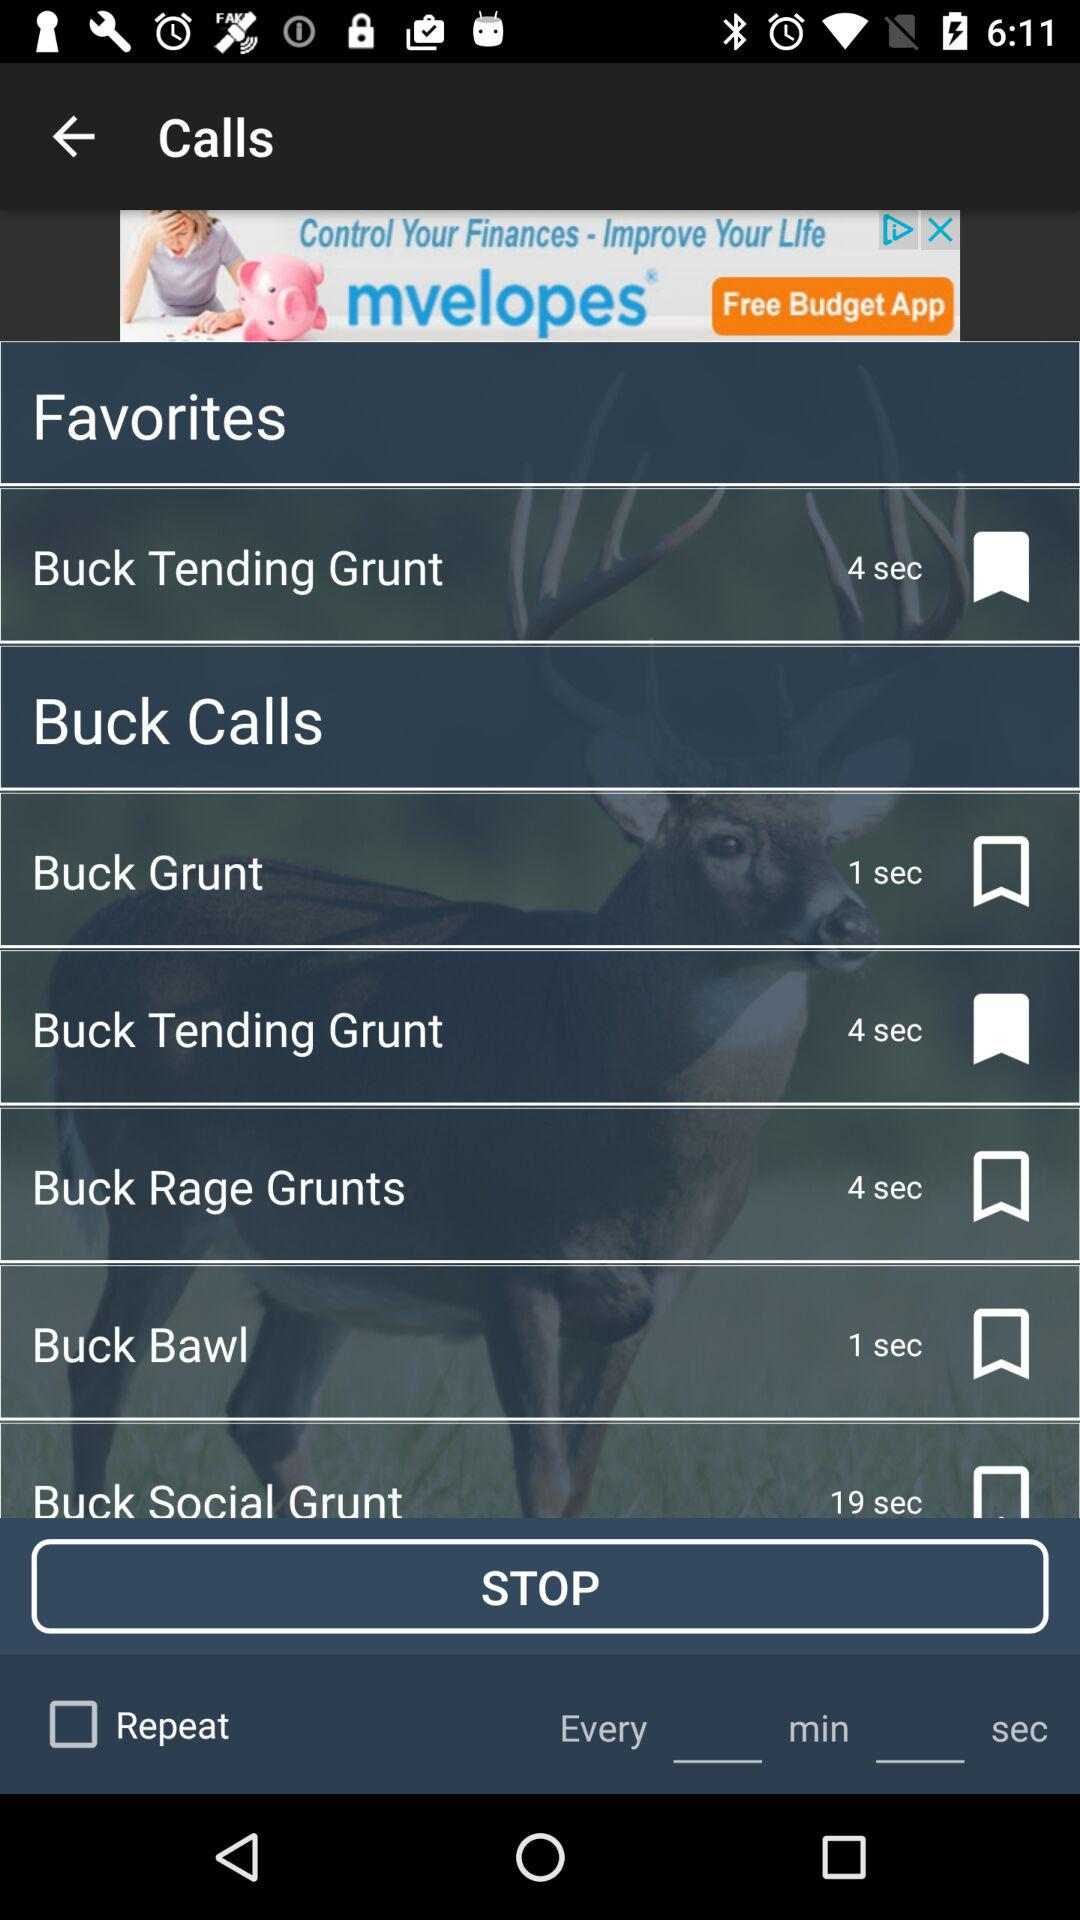How many Buck Grunt 1 recordings are there?
Answer the question using a single word or phrase. 2 